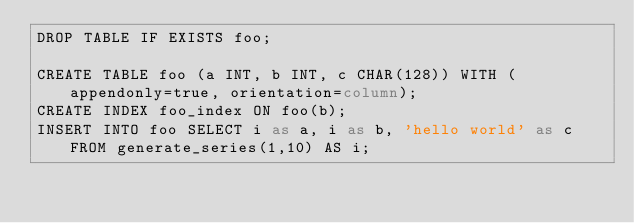Convert code to text. <code><loc_0><loc_0><loc_500><loc_500><_SQL_>DROP TABLE IF EXISTS foo;

CREATE TABLE foo (a INT, b INT, c CHAR(128)) WITH (appendonly=true, orientation=column);
CREATE INDEX foo_index ON foo(b);
INSERT INTO foo SELECT i as a, i as b, 'hello world' as c FROM generate_series(1,10) AS i;
</code> 